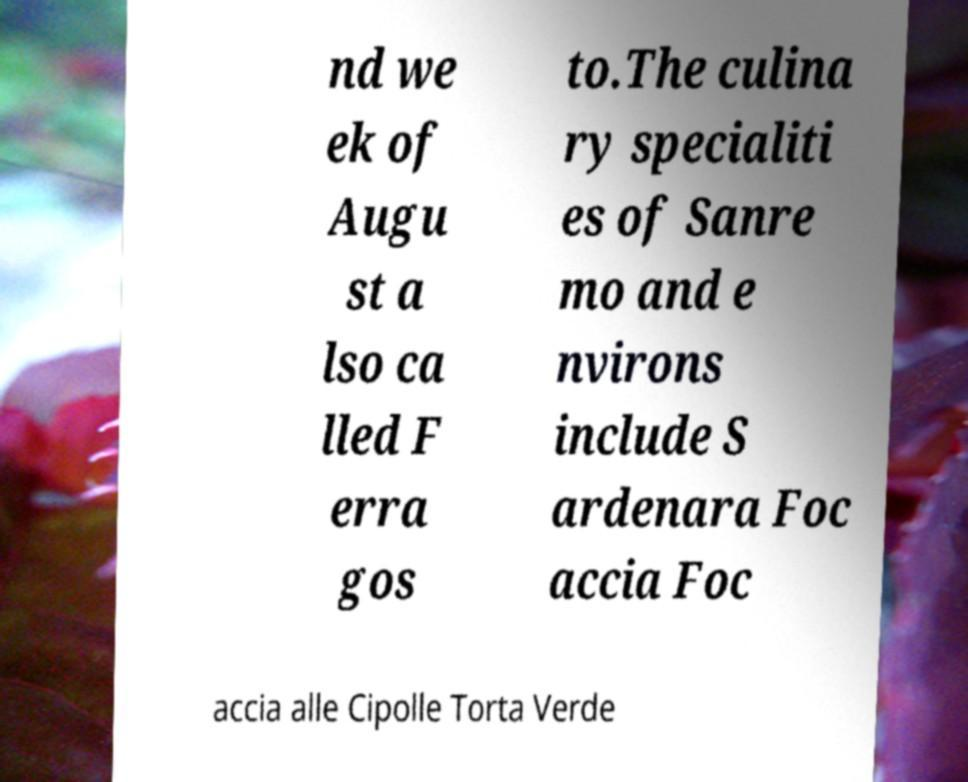I need the written content from this picture converted into text. Can you do that? nd we ek of Augu st a lso ca lled F erra gos to.The culina ry specialiti es of Sanre mo and e nvirons include S ardenara Foc accia Foc accia alle Cipolle Torta Verde 